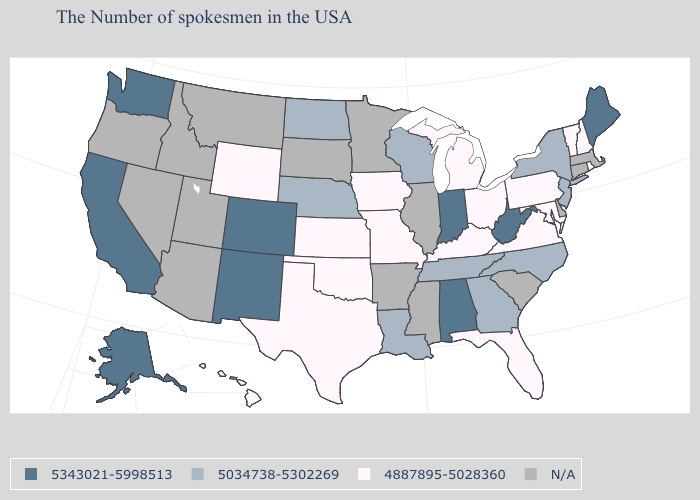Name the states that have a value in the range 5034738-5302269?
Write a very short answer. New York, New Jersey, North Carolina, Georgia, Tennessee, Wisconsin, Louisiana, Nebraska, North Dakota. Does Georgia have the lowest value in the USA?
Be succinct. No. How many symbols are there in the legend?
Be succinct. 4. Name the states that have a value in the range N/A?
Answer briefly. Massachusetts, Connecticut, Delaware, South Carolina, Illinois, Mississippi, Arkansas, Minnesota, South Dakota, Utah, Montana, Arizona, Idaho, Nevada, Oregon. Name the states that have a value in the range 4887895-5028360?
Be succinct. Rhode Island, New Hampshire, Vermont, Maryland, Pennsylvania, Virginia, Ohio, Florida, Michigan, Kentucky, Missouri, Iowa, Kansas, Oklahoma, Texas, Wyoming, Hawaii. What is the value of Mississippi?
Write a very short answer. N/A. What is the lowest value in the USA?
Short answer required. 4887895-5028360. What is the lowest value in the Northeast?
Give a very brief answer. 4887895-5028360. What is the value of Kansas?
Give a very brief answer. 4887895-5028360. How many symbols are there in the legend?
Write a very short answer. 4. Name the states that have a value in the range 5034738-5302269?
Quick response, please. New York, New Jersey, North Carolina, Georgia, Tennessee, Wisconsin, Louisiana, Nebraska, North Dakota. Which states have the lowest value in the South?
Answer briefly. Maryland, Virginia, Florida, Kentucky, Oklahoma, Texas. Does the map have missing data?
Quick response, please. Yes. Name the states that have a value in the range 4887895-5028360?
Quick response, please. Rhode Island, New Hampshire, Vermont, Maryland, Pennsylvania, Virginia, Ohio, Florida, Michigan, Kentucky, Missouri, Iowa, Kansas, Oklahoma, Texas, Wyoming, Hawaii. 